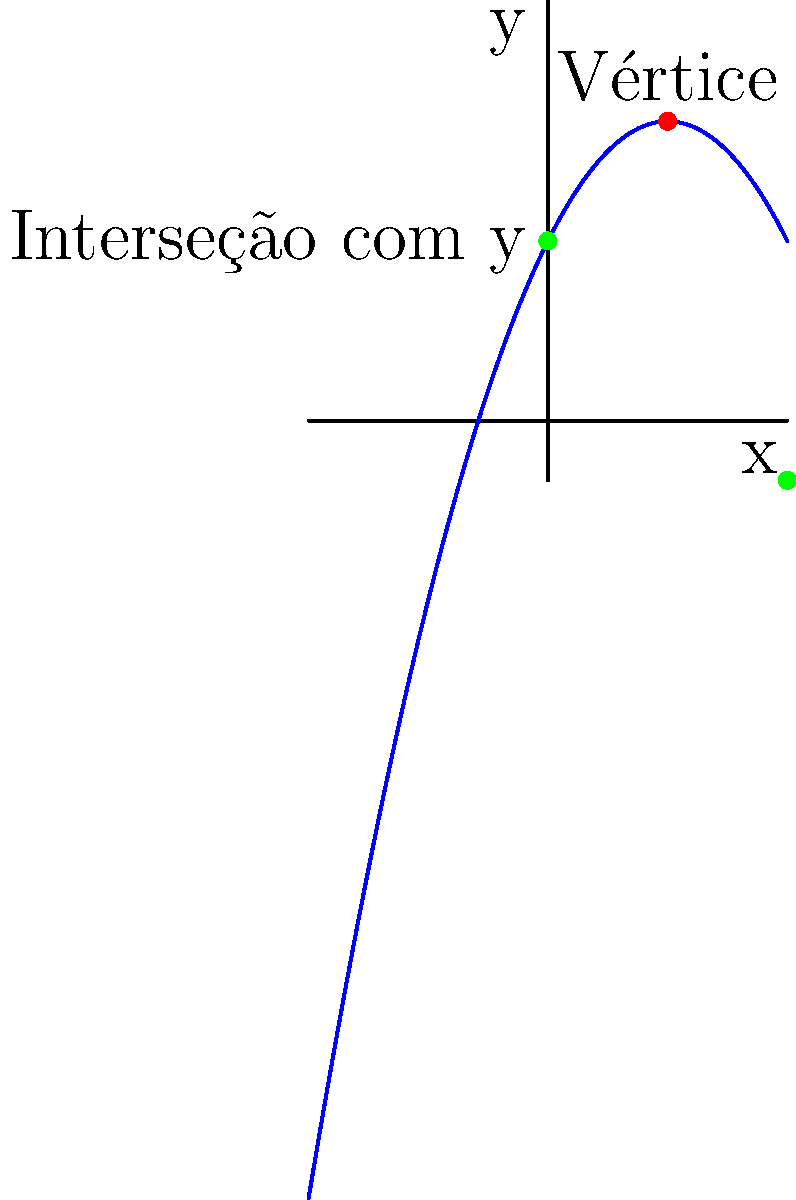Considere a função quadrática $f(x) = -0.5x^2 + 2x + 3$ representada no gráfico. Determine as coordenadas do vértice da parábola e explique como isso se relaciona com o valor máximo da função. Para encontrar as coordenadas do vértice da parábola, vamos seguir estes passos:

1) Para uma função quadrática na forma $f(x) = ax^2 + bx + c$, as coordenadas do vértice são dadas por $(-\frac{b}{2a}, f(-\frac{b}{2a}))$.

2) Em nossa função, $f(x) = -0.5x^2 + 2x + 3$, temos:
   $a = -0.5$
   $b = 2$
   $c = 3$

3) Calculando a coordenada x do vértice:
   $x = -\frac{b}{2a} = -\frac{2}{2(-0.5)} = -\frac{2}{-1} = 2$

4) Para encontrar a coordenada y, substituímos x por 2 na função original:
   $f(2) = -0.5(2)^2 + 2(2) + 3$
         $= -0.5(4) + 4 + 3$
         $= -2 + 4 + 3$
         $= 5$

5) Portanto, as coordenadas do vértice são (2, 5).

6) Como a parábola é voltada para baixo (a < 0), o vértice representa o ponto máximo da função.

Este resultado pode ser verificado no gráfico, onde o ponto vermelho indica o vértice da parábola.
Answer: (2, 5); ponto máximo da função 